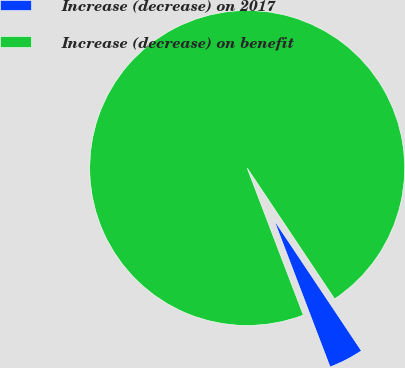Convert chart to OTSL. <chart><loc_0><loc_0><loc_500><loc_500><pie_chart><fcel>Increase (decrease) on 2017<fcel>Increase (decrease) on benefit<nl><fcel>3.57%<fcel>96.43%<nl></chart> 